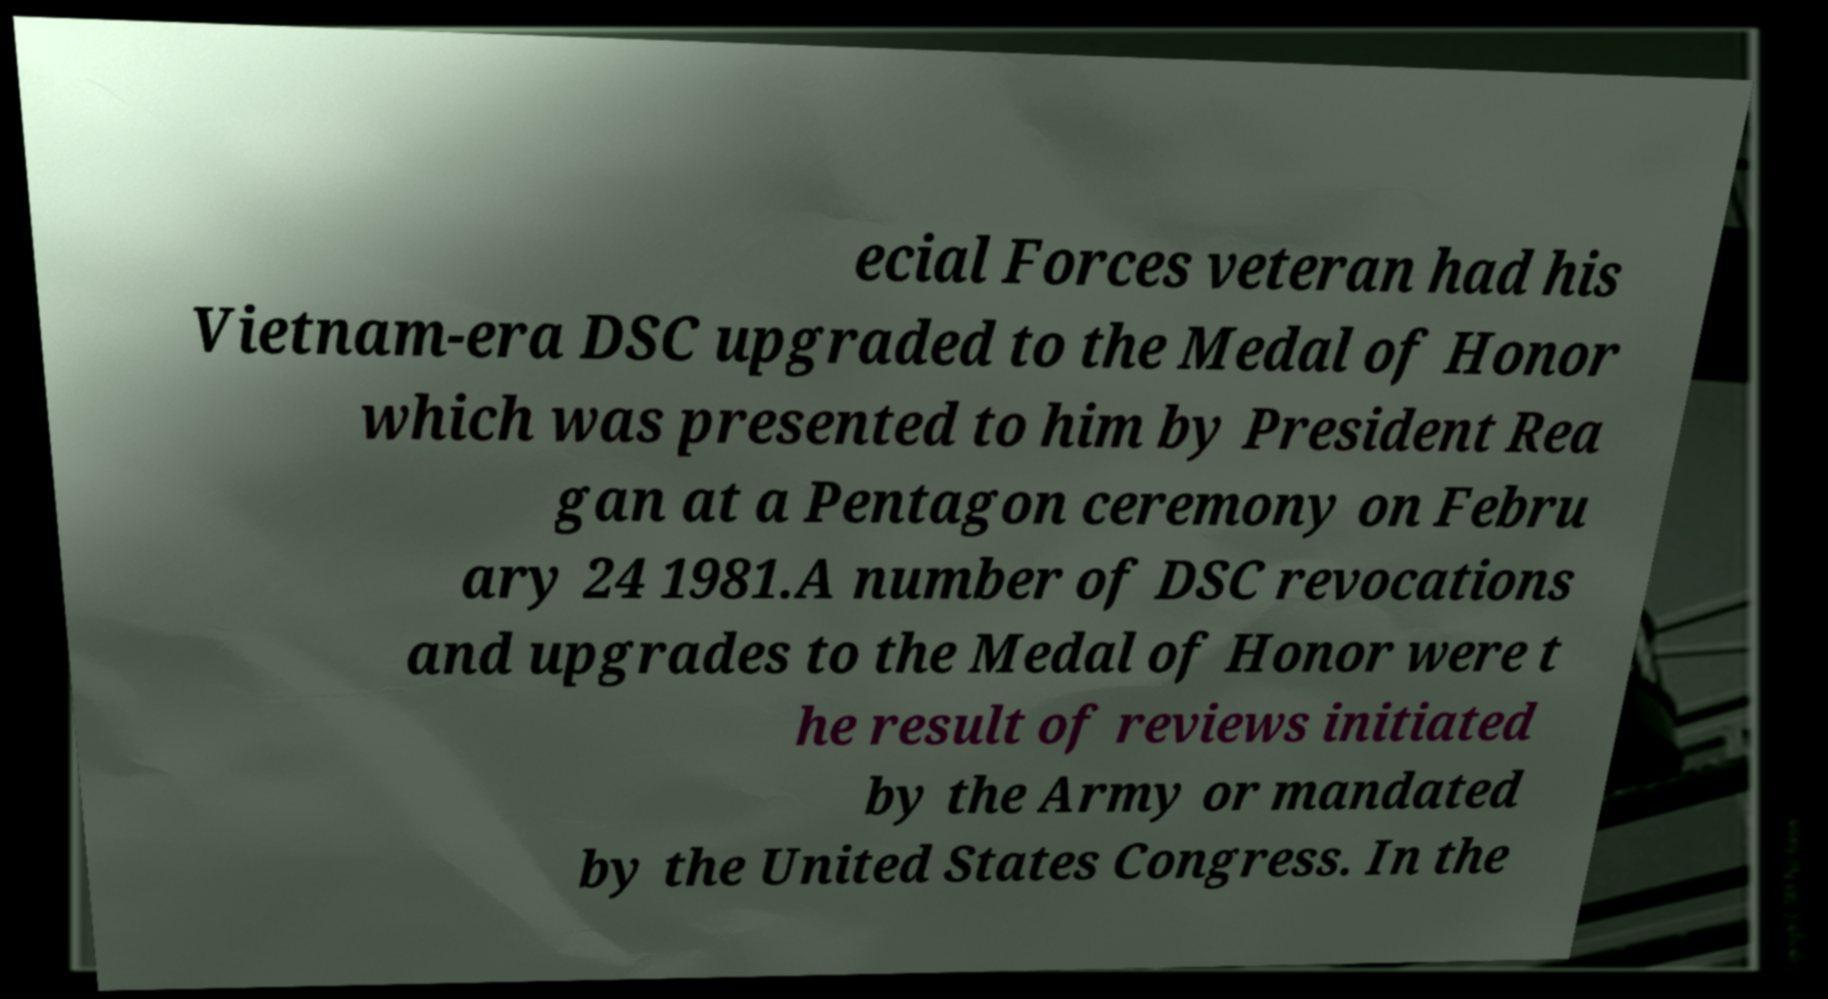What messages or text are displayed in this image? I need them in a readable, typed format. ecial Forces veteran had his Vietnam-era DSC upgraded to the Medal of Honor which was presented to him by President Rea gan at a Pentagon ceremony on Febru ary 24 1981.A number of DSC revocations and upgrades to the Medal of Honor were t he result of reviews initiated by the Army or mandated by the United States Congress. In the 